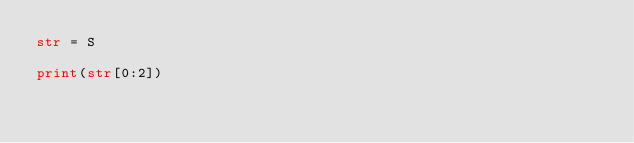Convert code to text. <code><loc_0><loc_0><loc_500><loc_500><_Python_>str = S

print(str[0:2])
</code> 